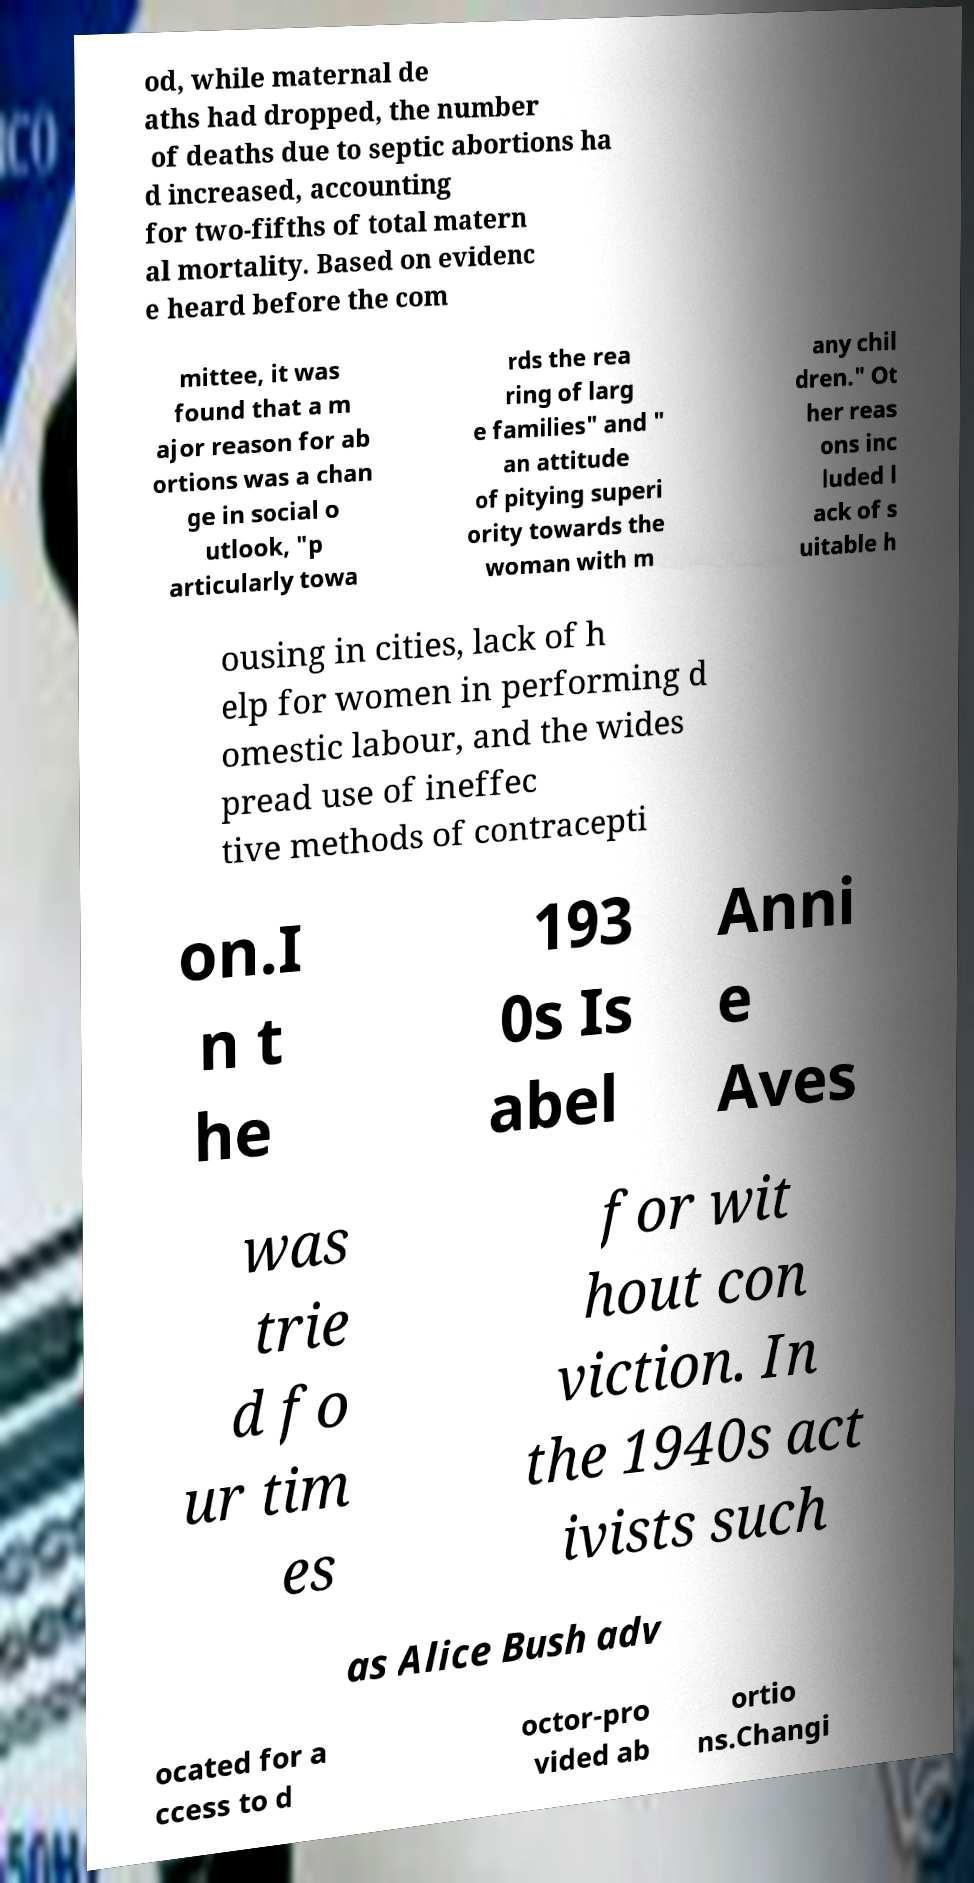There's text embedded in this image that I need extracted. Can you transcribe it verbatim? od, while maternal de aths had dropped, the number of deaths due to septic abortions ha d increased, accounting for two-fifths of total matern al mortality. Based on evidenc e heard before the com mittee, it was found that a m ajor reason for ab ortions was a chan ge in social o utlook, "p articularly towa rds the rea ring of larg e families" and " an attitude of pitying superi ority towards the woman with m any chil dren." Ot her reas ons inc luded l ack of s uitable h ousing in cities, lack of h elp for women in performing d omestic labour, and the wides pread use of ineffec tive methods of contracepti on.I n t he 193 0s Is abel Anni e Aves was trie d fo ur tim es for wit hout con viction. In the 1940s act ivists such as Alice Bush adv ocated for a ccess to d octor-pro vided ab ortio ns.Changi 